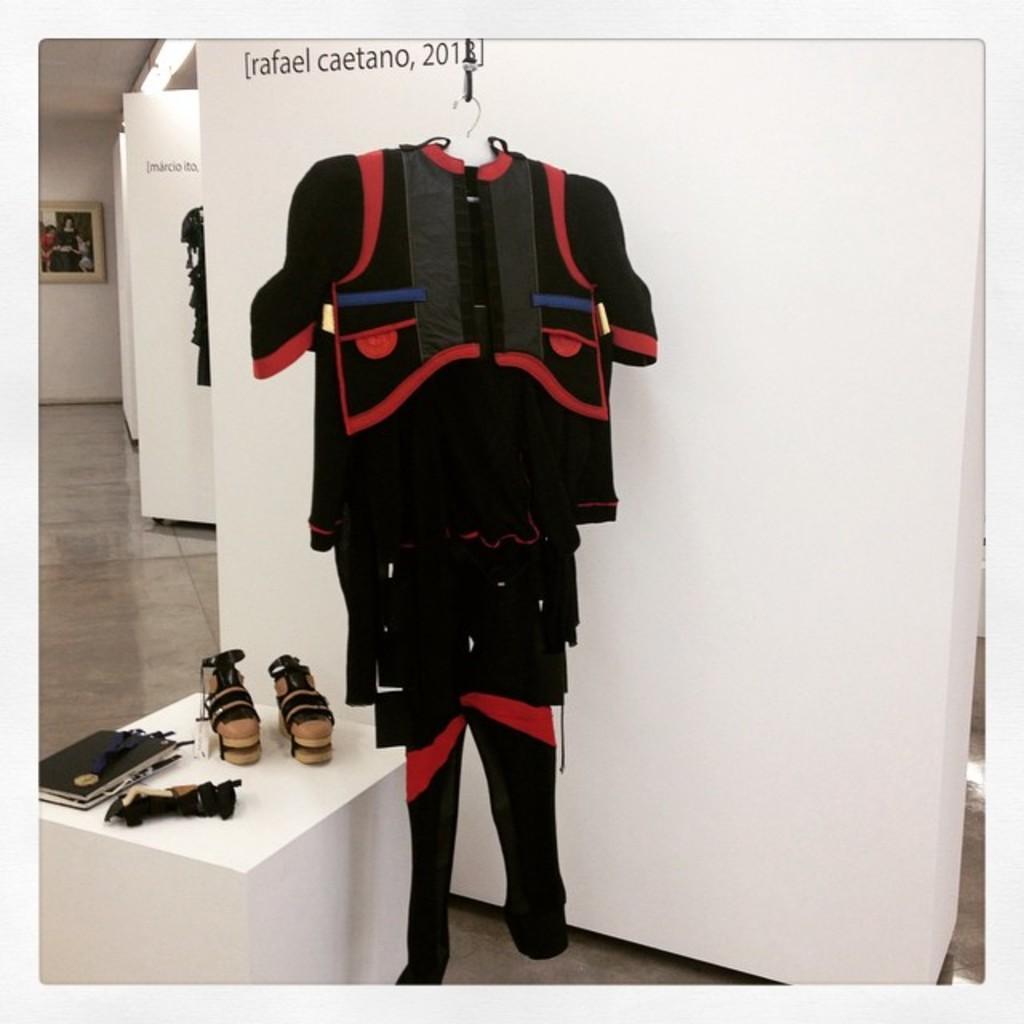Could you give a brief overview of what you see in this image? In this image I can see the dress in red and black color and I can also see the pair of shoe, book and few objects on the table. In the background I can see the frame attached to the wall and the wall is in white color. 